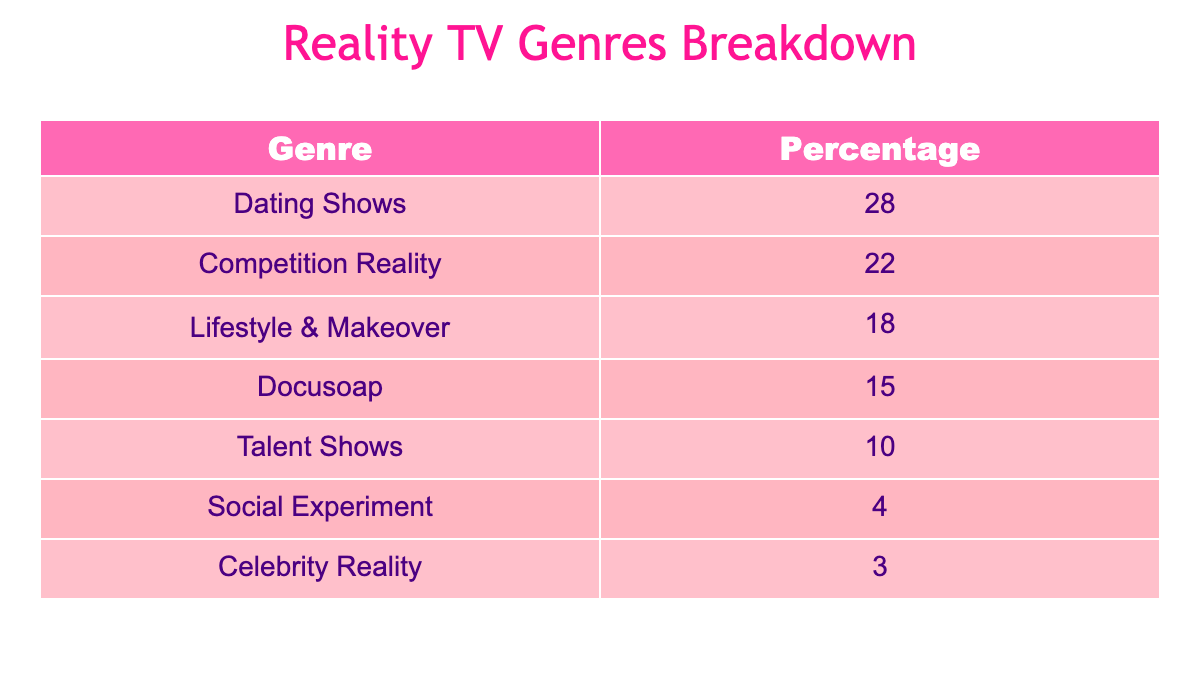What percentage of airtime is dedicated to Dating Shows? Looking at the table, Dating Shows are listed with a percentage of 28%. This means they account for 28% of the total airtime on major networks for reality TV.
Answer: 28% Which genre has the least airtime? According to the table, the genre with the least airtime is Celebrity Reality, which has a percentage of 3%.
Answer: 3% What is the total percentage of airtime for Competition Reality and Talent Shows combined? To find the total, we need to add the percentages for Competition Reality (22%) and Talent Shows (10%). Thus, 22 + 10 = 32%.
Answer: 32% Is it true that Lifestyle & Makeover shows have more airtime than Talent Shows? The table shows that Lifestyle & Makeover occupies 18% of airtime, while Talent Shows have 10%. Since 18% is greater than 10%, this statement is true.
Answer: Yes What percentage of airtime is dedicated to Social Experiment and Celebrity Reality combined? We need to add the percentages for Social Experiment (4%) and Celebrity Reality (3%). Calculating this gives us 4 + 3 = 7%.
Answer: 7% Which genre is more prevalent, Docusoap or Lifestyle & Makeover? Docusoap has a percentage of 15% and Lifestyle & Makeover has 18%. Therefore, Lifestyle & Makeover is more prevalent because 18% is greater than 15%.
Answer: Lifestyle & Makeover What is the percentage difference between the top genre and the bottom genre? The top genre, Dating Shows, has 28%, and the bottom genre, Celebrity Reality, has 3%. The difference is calculated as 28 - 3 = 25%.
Answer: 25% If we combine the airtime percentages of Dating Shows, Competition Reality, and Lifestyle & Makeover, what do we get? We need to add the percentages: Dating Shows (28%) + Competition Reality (22%) + Lifestyle & Makeover (18%). Thus, 28 + 22 + 18 = 68%.
Answer: 68% Are Competition Reality shows more than twice as prevalent as Social Experiment shows? Competition Reality is at 22%, while Social Experiment is at 4%. Since 22% is more than twice of 4% (which would be 8%), the statement is true.
Answer: Yes 